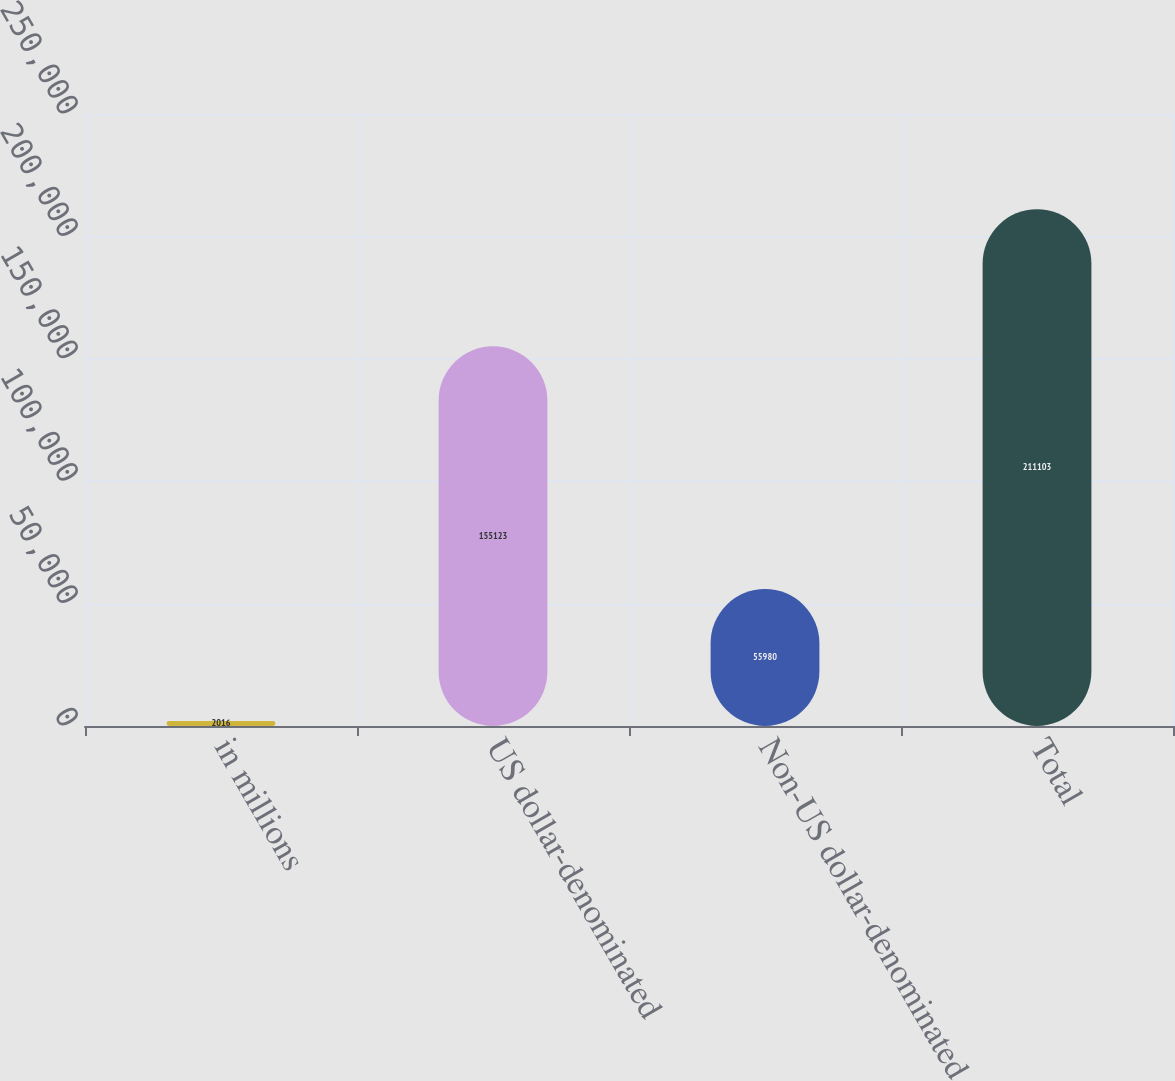<chart> <loc_0><loc_0><loc_500><loc_500><bar_chart><fcel>in millions<fcel>US dollar-denominated<fcel>Non-US dollar-denominated<fcel>Total<nl><fcel>2016<fcel>155123<fcel>55980<fcel>211103<nl></chart> 